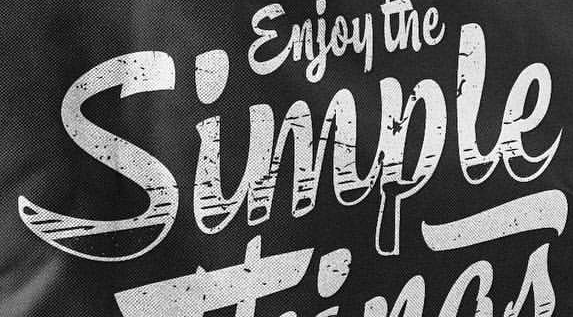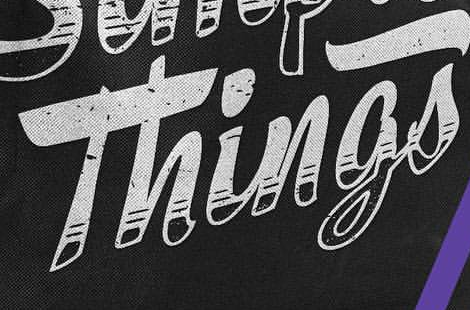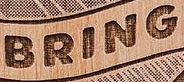What words can you see in these images in sequence, separated by a semicolon? Simple; Things; BRING 